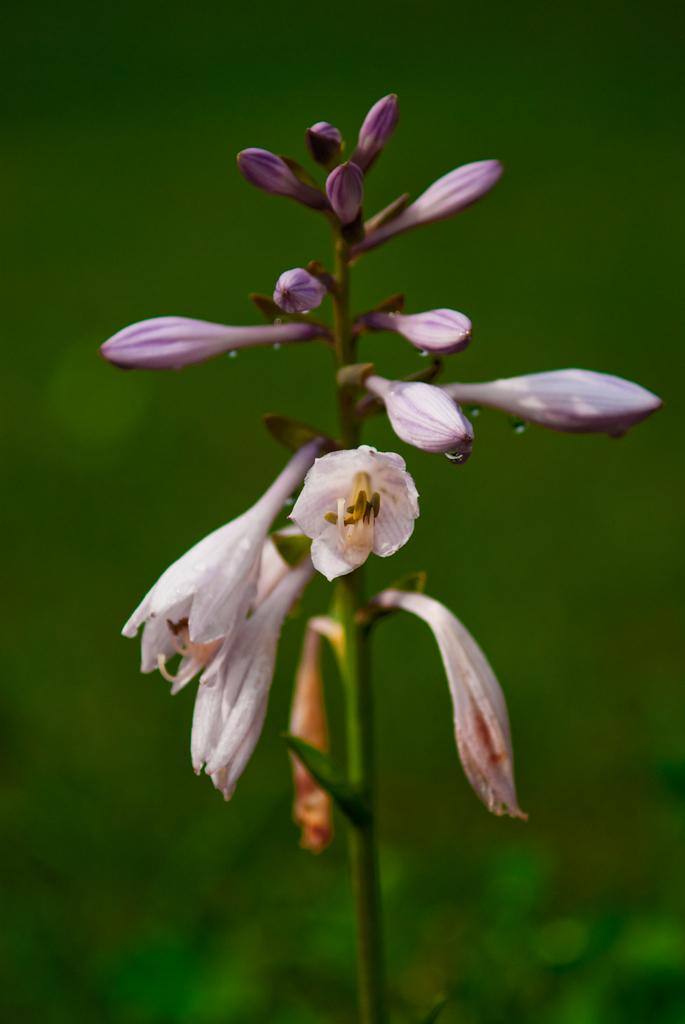What type of plants can be seen in the image? There are flowers in the image. Can you describe the stage of growth for the flowers in the image? There are buds on the stem in the image. What type of current can be seen flowing through the arm in the image? There is no arm or current present in the image; it features flowers and buds on the stem. 